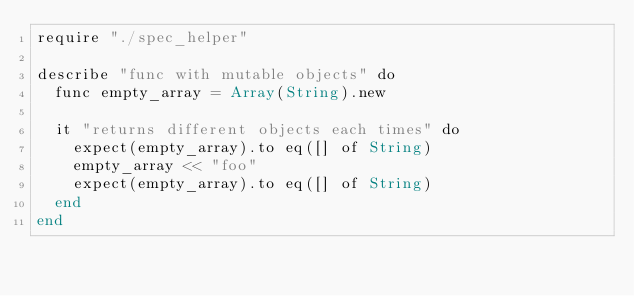<code> <loc_0><loc_0><loc_500><loc_500><_Crystal_>require "./spec_helper"

describe "func with mutable objects" do
  func empty_array = Array(String).new

  it "returns different objects each times" do
    expect(empty_array).to eq([] of String)
    empty_array << "foo"
    expect(empty_array).to eq([] of String)
  end
end
</code> 